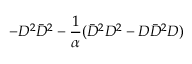Convert formula to latex. <formula><loc_0><loc_0><loc_500><loc_500>- D ^ { 2 } \bar { D } ^ { 2 } - { \frac { 1 } { \alpha } } ( \bar { D } ^ { 2 } D ^ { 2 } - D \bar { D } ^ { 2 } D )</formula> 